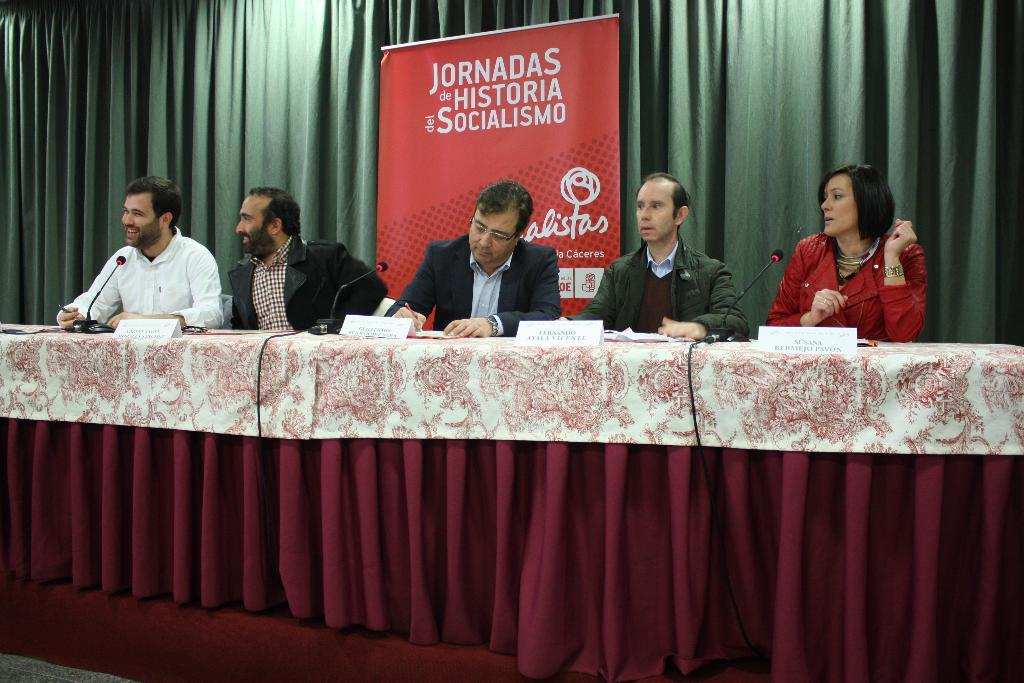How many people are present in the image? There are four persons in the image. Can you describe the woman in the image? The woman is sitting in a chair. Where is the chair located in relation to other objects? The chair is near a table or podium. What objects are present that might be used for speaking or presenting? There are name boards and microphones in the image. What can be seen in the background of the image? There is a hoarding and a curtain in the background of the image. What type of stew is being served at the event in the image? There is no mention of food or a specific event in the image, so it is not possible to determine if any type of stew is being served. 